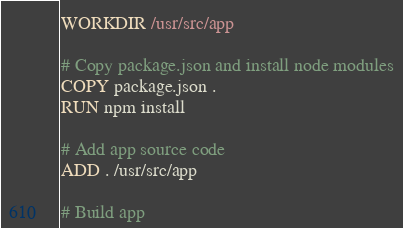<code> <loc_0><loc_0><loc_500><loc_500><_Dockerfile_>WORKDIR /usr/src/app

# Copy package.json and install node modules
COPY package.json .
RUN npm install

# Add app source code
ADD . /usr/src/app

# Build app</code> 